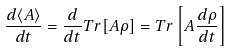Convert formula to latex. <formula><loc_0><loc_0><loc_500><loc_500>\frac { d \langle A \rangle } { d t } = \frac { d } { d t } T r [ A \rho ] = T r \left [ A \frac { d \rho } { d t } \right ]</formula> 